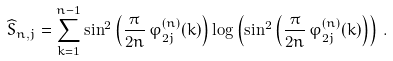Convert formula to latex. <formula><loc_0><loc_0><loc_500><loc_500>\widehat { S } _ { n , j } = \sum _ { k = 1 } ^ { n - 1 } \sin ^ { 2 } \left ( \frac { \pi } { 2 n } \, \varphi _ { 2 j } ^ { ( n ) } ( k ) \right ) \log \left ( \sin ^ { 2 } \left ( \frac { \pi } { 2 n } \, \varphi _ { 2 j } ^ { ( n ) } ( k ) \right ) \right ) \, .</formula> 